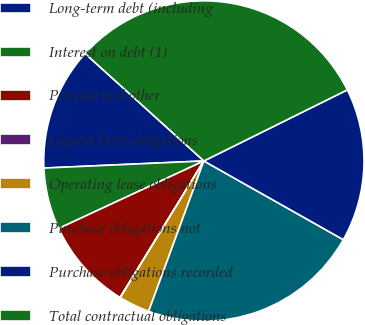Convert chart to OTSL. <chart><loc_0><loc_0><loc_500><loc_500><pie_chart><fcel>Long-term debt (including<fcel>Interest on debt (1)<fcel>Pension and other<fcel>Capital lease obligations<fcel>Operating lease obligations<fcel>Purchase obligations not<fcel>Purchase obligations recorded<fcel>Total contractual obligations<nl><fcel>12.41%<fcel>6.22%<fcel>9.31%<fcel>0.03%<fcel>3.13%<fcel>22.42%<fcel>15.5%<fcel>30.97%<nl></chart> 